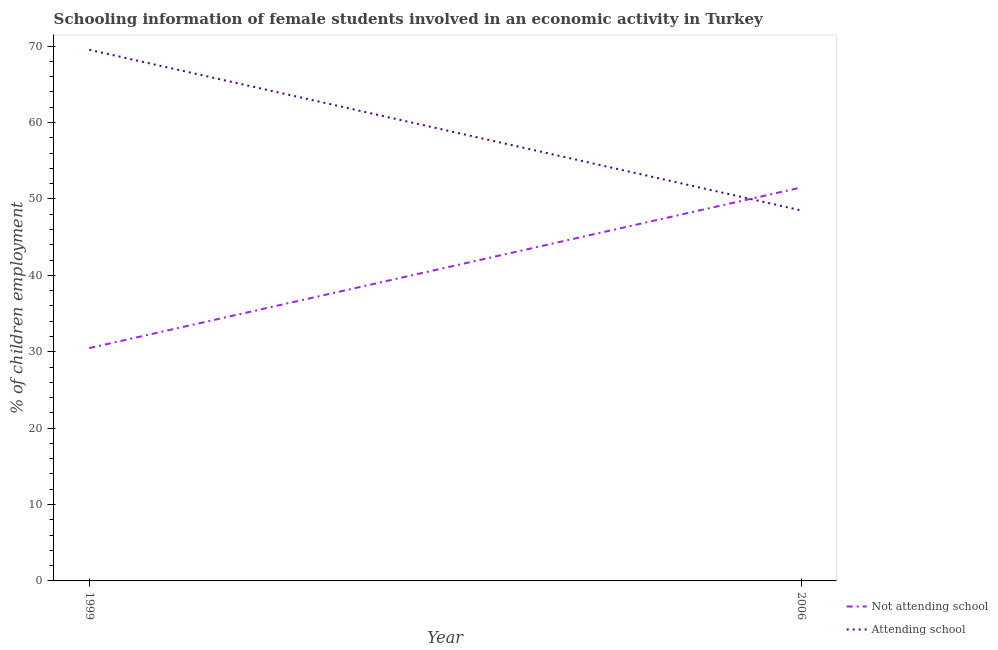Does the line corresponding to percentage of employed females who are attending school intersect with the line corresponding to percentage of employed females who are not attending school?
Your answer should be very brief. Yes. Is the number of lines equal to the number of legend labels?
Your response must be concise. Yes. What is the percentage of employed females who are not attending school in 1999?
Ensure brevity in your answer.  30.48. Across all years, what is the maximum percentage of employed females who are attending school?
Provide a short and direct response. 69.52. Across all years, what is the minimum percentage of employed females who are not attending school?
Your response must be concise. 30.48. In which year was the percentage of employed females who are not attending school maximum?
Your answer should be very brief. 2006. What is the total percentage of employed females who are not attending school in the graph?
Provide a succinct answer. 81.98. What is the difference between the percentage of employed females who are attending school in 1999 and that in 2006?
Keep it short and to the point. 21.02. What is the difference between the percentage of employed females who are not attending school in 2006 and the percentage of employed females who are attending school in 1999?
Provide a succinct answer. -18.02. What is the average percentage of employed females who are attending school per year?
Your answer should be very brief. 59.01. In the year 2006, what is the difference between the percentage of employed females who are not attending school and percentage of employed females who are attending school?
Your response must be concise. 3. In how many years, is the percentage of employed females who are attending school greater than 12 %?
Offer a terse response. 2. What is the ratio of the percentage of employed females who are not attending school in 1999 to that in 2006?
Offer a terse response. 0.59. Is the percentage of employed females who are not attending school in 1999 less than that in 2006?
Ensure brevity in your answer.  Yes. In how many years, is the percentage of employed females who are not attending school greater than the average percentage of employed females who are not attending school taken over all years?
Provide a succinct answer. 1. Does the percentage of employed females who are attending school monotonically increase over the years?
Make the answer very short. No. Is the percentage of employed females who are attending school strictly greater than the percentage of employed females who are not attending school over the years?
Ensure brevity in your answer.  No. Is the percentage of employed females who are not attending school strictly less than the percentage of employed females who are attending school over the years?
Keep it short and to the point. No. Are the values on the major ticks of Y-axis written in scientific E-notation?
Ensure brevity in your answer.  No. Does the graph contain grids?
Keep it short and to the point. No. What is the title of the graph?
Provide a short and direct response. Schooling information of female students involved in an economic activity in Turkey. Does "Adolescent fertility rate" appear as one of the legend labels in the graph?
Offer a very short reply. No. What is the label or title of the Y-axis?
Keep it short and to the point. % of children employment. What is the % of children employment in Not attending school in 1999?
Give a very brief answer. 30.48. What is the % of children employment of Attending school in 1999?
Provide a succinct answer. 69.52. What is the % of children employment of Not attending school in 2006?
Ensure brevity in your answer.  51.5. What is the % of children employment in Attending school in 2006?
Offer a terse response. 48.5. Across all years, what is the maximum % of children employment of Not attending school?
Keep it short and to the point. 51.5. Across all years, what is the maximum % of children employment of Attending school?
Your answer should be compact. 69.52. Across all years, what is the minimum % of children employment in Not attending school?
Provide a short and direct response. 30.48. Across all years, what is the minimum % of children employment of Attending school?
Give a very brief answer. 48.5. What is the total % of children employment of Not attending school in the graph?
Provide a succinct answer. 81.98. What is the total % of children employment of Attending school in the graph?
Your response must be concise. 118.02. What is the difference between the % of children employment of Not attending school in 1999 and that in 2006?
Offer a terse response. -21.02. What is the difference between the % of children employment in Attending school in 1999 and that in 2006?
Make the answer very short. 21.02. What is the difference between the % of children employment of Not attending school in 1999 and the % of children employment of Attending school in 2006?
Provide a short and direct response. -18.02. What is the average % of children employment of Not attending school per year?
Provide a short and direct response. 40.99. What is the average % of children employment of Attending school per year?
Give a very brief answer. 59.01. In the year 1999, what is the difference between the % of children employment in Not attending school and % of children employment in Attending school?
Give a very brief answer. -39.05. What is the ratio of the % of children employment of Not attending school in 1999 to that in 2006?
Keep it short and to the point. 0.59. What is the ratio of the % of children employment of Attending school in 1999 to that in 2006?
Give a very brief answer. 1.43. What is the difference between the highest and the second highest % of children employment in Not attending school?
Your answer should be compact. 21.02. What is the difference between the highest and the second highest % of children employment in Attending school?
Ensure brevity in your answer.  21.02. What is the difference between the highest and the lowest % of children employment of Not attending school?
Your answer should be very brief. 21.02. What is the difference between the highest and the lowest % of children employment in Attending school?
Provide a short and direct response. 21.02. 